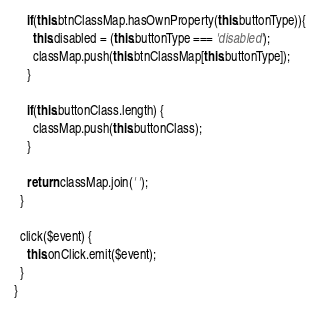Convert code to text. <code><loc_0><loc_0><loc_500><loc_500><_TypeScript_>    if(this.btnClassMap.hasOwnProperty(this.buttonType)){
      this.disabled = (this.buttonType === 'disabled');
      classMap.push(this.btnClassMap[this.buttonType]);
    }

    if(this.buttonClass.length) {
      classMap.push(this.buttonClass);
    }

    return classMap.join(' ');
  }

  click($event) {
    this.onClick.emit($event);
  }
}
</code> 